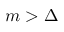Convert formula to latex. <formula><loc_0><loc_0><loc_500><loc_500>m > \Delta</formula> 